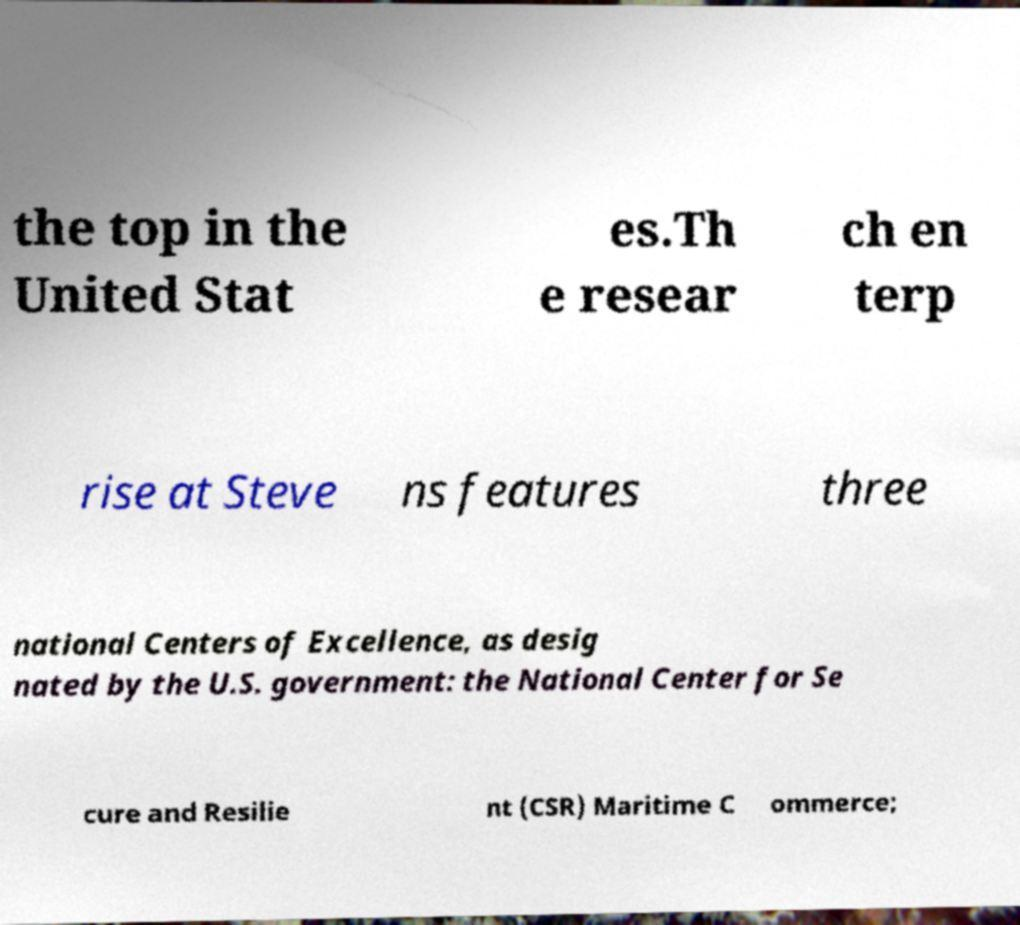Could you extract and type out the text from this image? the top in the United Stat es.Th e resear ch en terp rise at Steve ns features three national Centers of Excellence, as desig nated by the U.S. government: the National Center for Se cure and Resilie nt (CSR) Maritime C ommerce; 